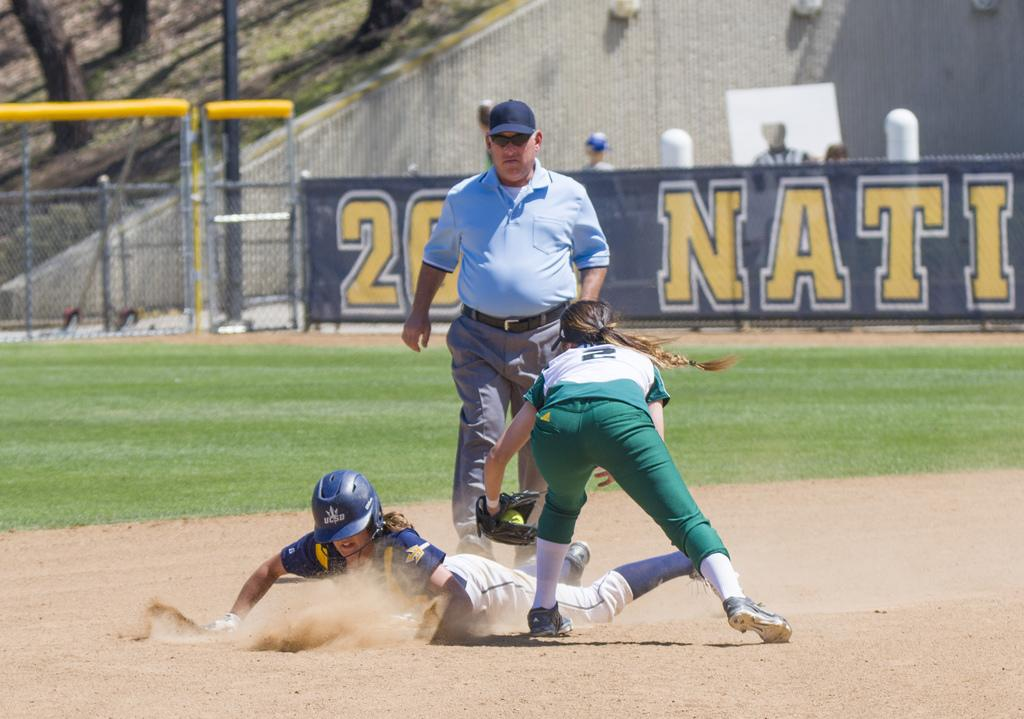Provide a one-sentence caption for the provided image. A softball player numbered 2 trying to stop a player at the base. 